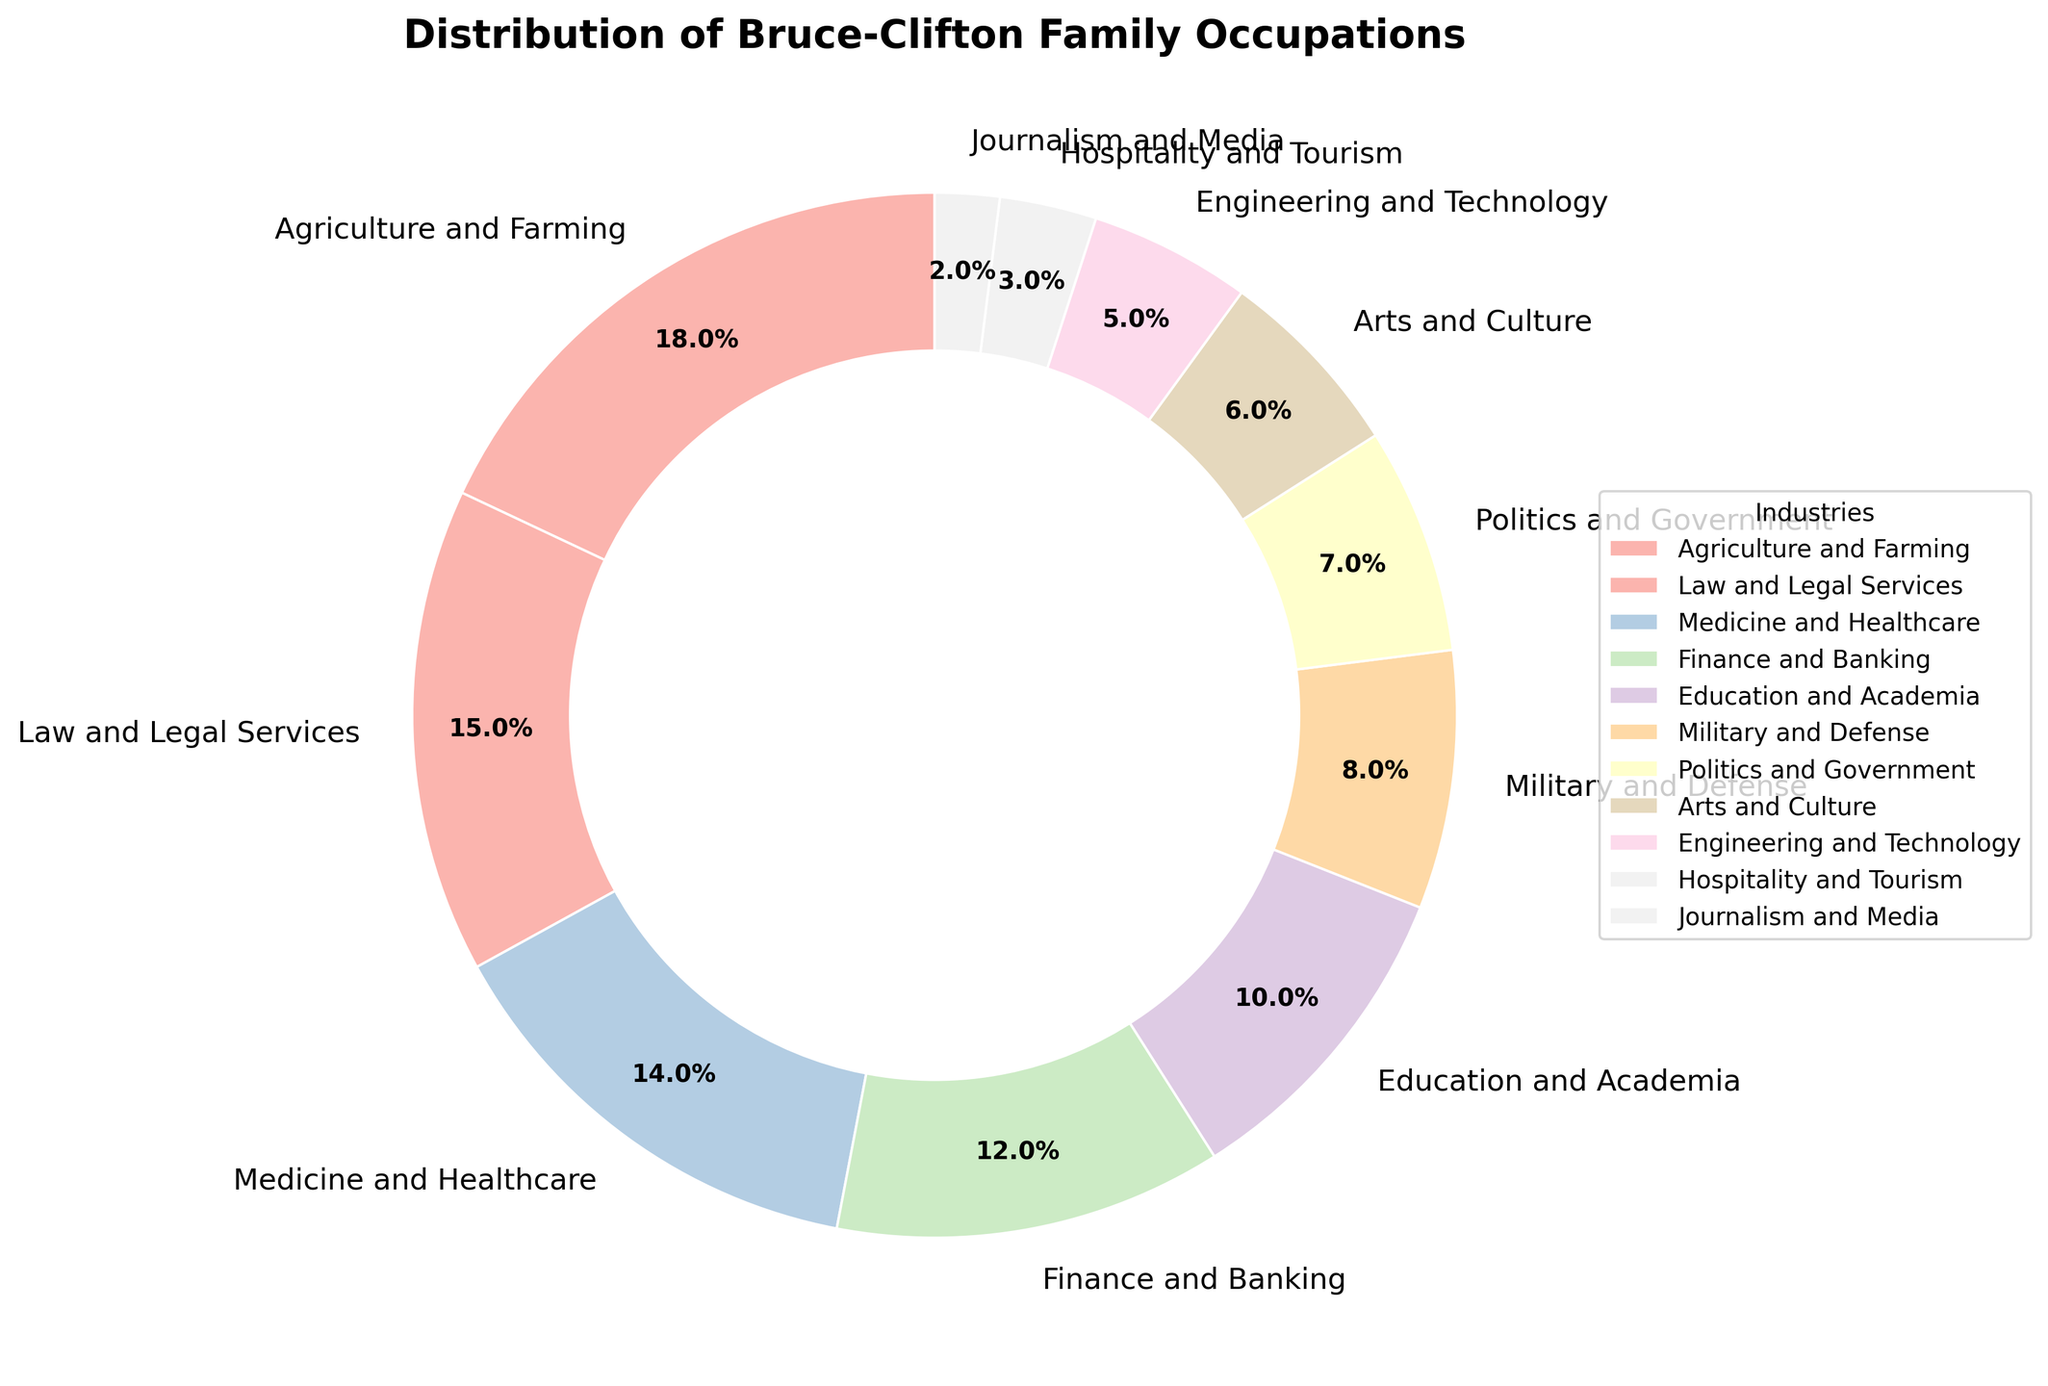Which industry has the highest representation in the Bruce-Clifton family occupations? The pie chart shows the percentage distribution of different industries. The slice with the highest percentage is labeled "Agriculture and Farming" with 18%.
Answer: Agriculture and Farming What is the combined percentage of family members working in Medicine and Healthcare, and Finance and Banking? First, identify the percentages for the two industries from the chart. Medicine and Healthcare is 14% and Finance and Banking is 12%. Adding them together: 14% + 12% = 26%.
Answer: 26% How does the percentage of family members in Education and Academia compare to those in Engineering and Technology? From the chart, Education and Academia accounts for 10% and Engineering and Technology accounts for 5%. Comparing the two, Education and Academia has a higher percentage than Engineering and Technology.
Answer: Education and Academia is higher What is the difference in percentage between the family members working in Politics and Government and those in Arts and Culture? The chart shows 7% for Politics and Government and 6% for Arts and Culture. The difference can be calculated as 7% - 6% = 1%.
Answer: 1% Which three industries collectively account for the smallest percentage of Bruce-Clifton family occupations? Observe the three smallest slices on the chart. Hospitality and Tourism (3%), Journalism and Media (2%), and Engineering and Technology (5%) have the smallest percentages. Together, they account for 3% + 2% + 5% = 10%.
Answer: Hospitality and Tourism, Journalism and Media, Engineering and Technology 